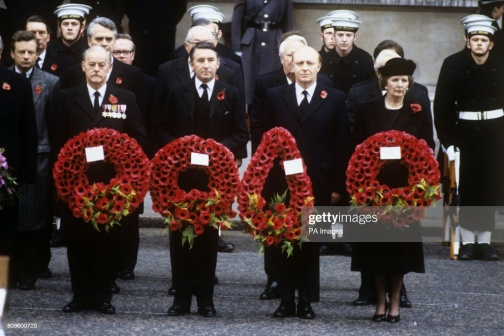Imagine you are one of the people in this event. Describe your feelings and thoughts. Standing among the participants at this solemn event, I feel a profound sense of reverence and reflection. The weight of history and the sacrifices made are palpable in the air. As I hold the wreath of vivid red poppies, my thoughts are with those we are here to honor - the brave individuals whose lives were dedicated and ultimately lost in service. The formal attire and the serious expressions around me further underscore the gravity of the moment. I am reminded of the camaraderie and the unspoken bond shared by those who serve, and the enduring significance of remembering and paying tribute to such sacrifices. The presence of my fellow participants, each holding a wreath, reinforces the collective nature of our remembrance. There's a deep, shared connection in this act of honoring the past, and it is both humbling and inspiring to be part of this reverent gathering. 